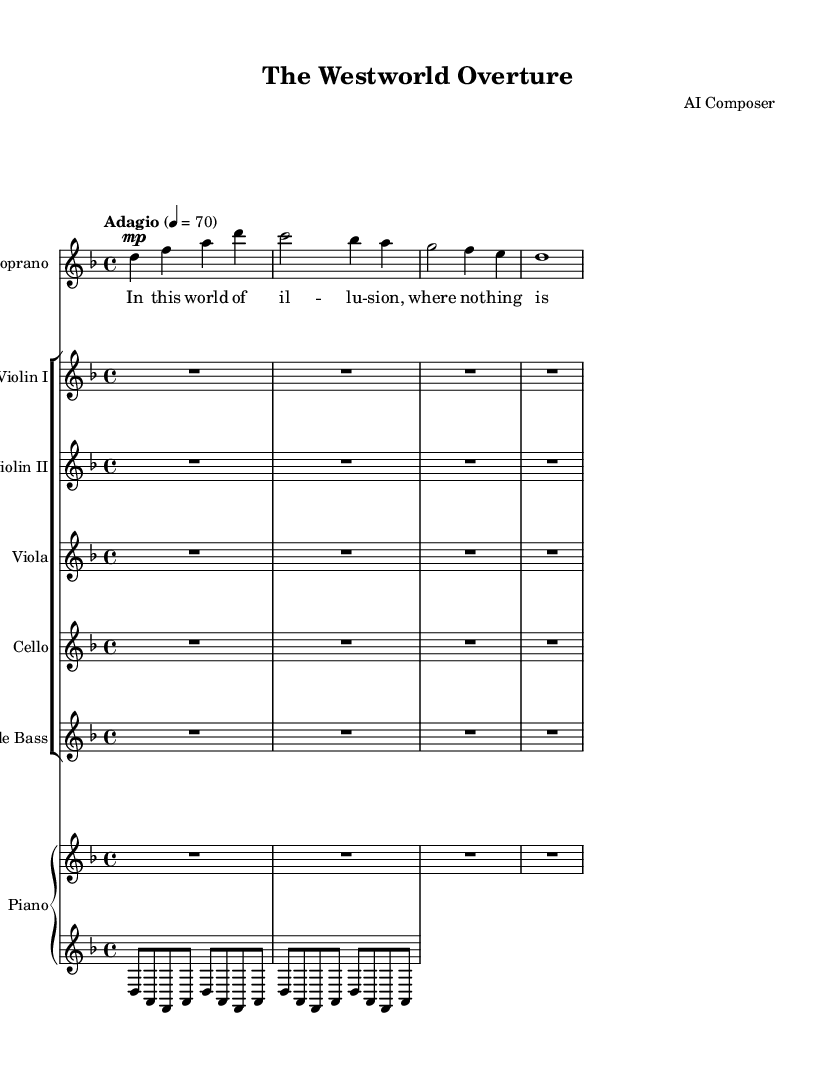What is the key signature of this music? The key signature is indicated by the sharps or flats at the beginning of the staff. In this case, there's a 'B-flat' which indicates the presence of B-flat in the scale. Since there are no sharps indicated, we can conclude it supports a key signature of D minor.
Answer: D minor What is the time signature used in this piece? The time signature is listed at the beginning, represented by the fraction in the sheet music. Here, we can see the '4/4' time signature, indicating that there are four beats in every measure and the quarter note gets one beat.
Answer: 4/4 What tempo marking is indicated for this composition? The tempo marking is stated above the staff, which sets the pace for the piece. In this case, "Adagio" is the term provided, indicating a slow tempo. The numeric marking of "4 = 70" adds clarity on the beats per minute as well.
Answer: Adagio How many measures are present in the soprano part? We count the number of vertical bar lines or measure lines present in the soprano part. By visual inspection, we can see there are four measures in the provided soprano notation.
Answer: Four What type of instruments are included in the ensemble? The sheet music indicates the specific instruments involved by their labels at the beginning of each staff. This includes strings (violin, viola, cello, double bass) and a piano.
Answer: Strings and piano What is the dynamic marking for the soprano voice? The dynamic marking is placed immediately before the note to instruct how loudly or softly to sing. In this case, it is marked as 'mp', which stands for 'mezzo-piano', instructing a moderately soft dynamic level.
Answer: Mezzo-piano Which opera adaptation inspired this piece of music? The lyrics provided in the music suggest a thematic exploration reminiscent of the TV series "Westworld," indicating that the opera adaptation is based on this complex narrative series.
Answer: Westworld 